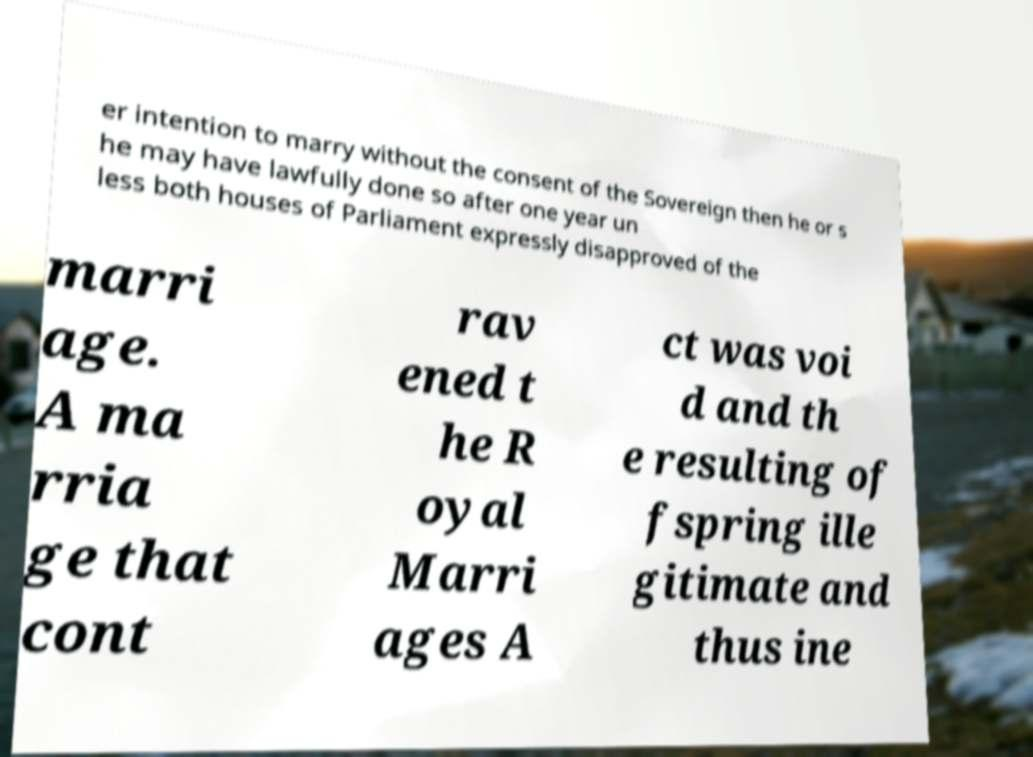I need the written content from this picture converted into text. Can you do that? er intention to marry without the consent of the Sovereign then he or s he may have lawfully done so after one year un less both houses of Parliament expressly disapproved of the marri age. A ma rria ge that cont rav ened t he R oyal Marri ages A ct was voi d and th e resulting of fspring ille gitimate and thus ine 